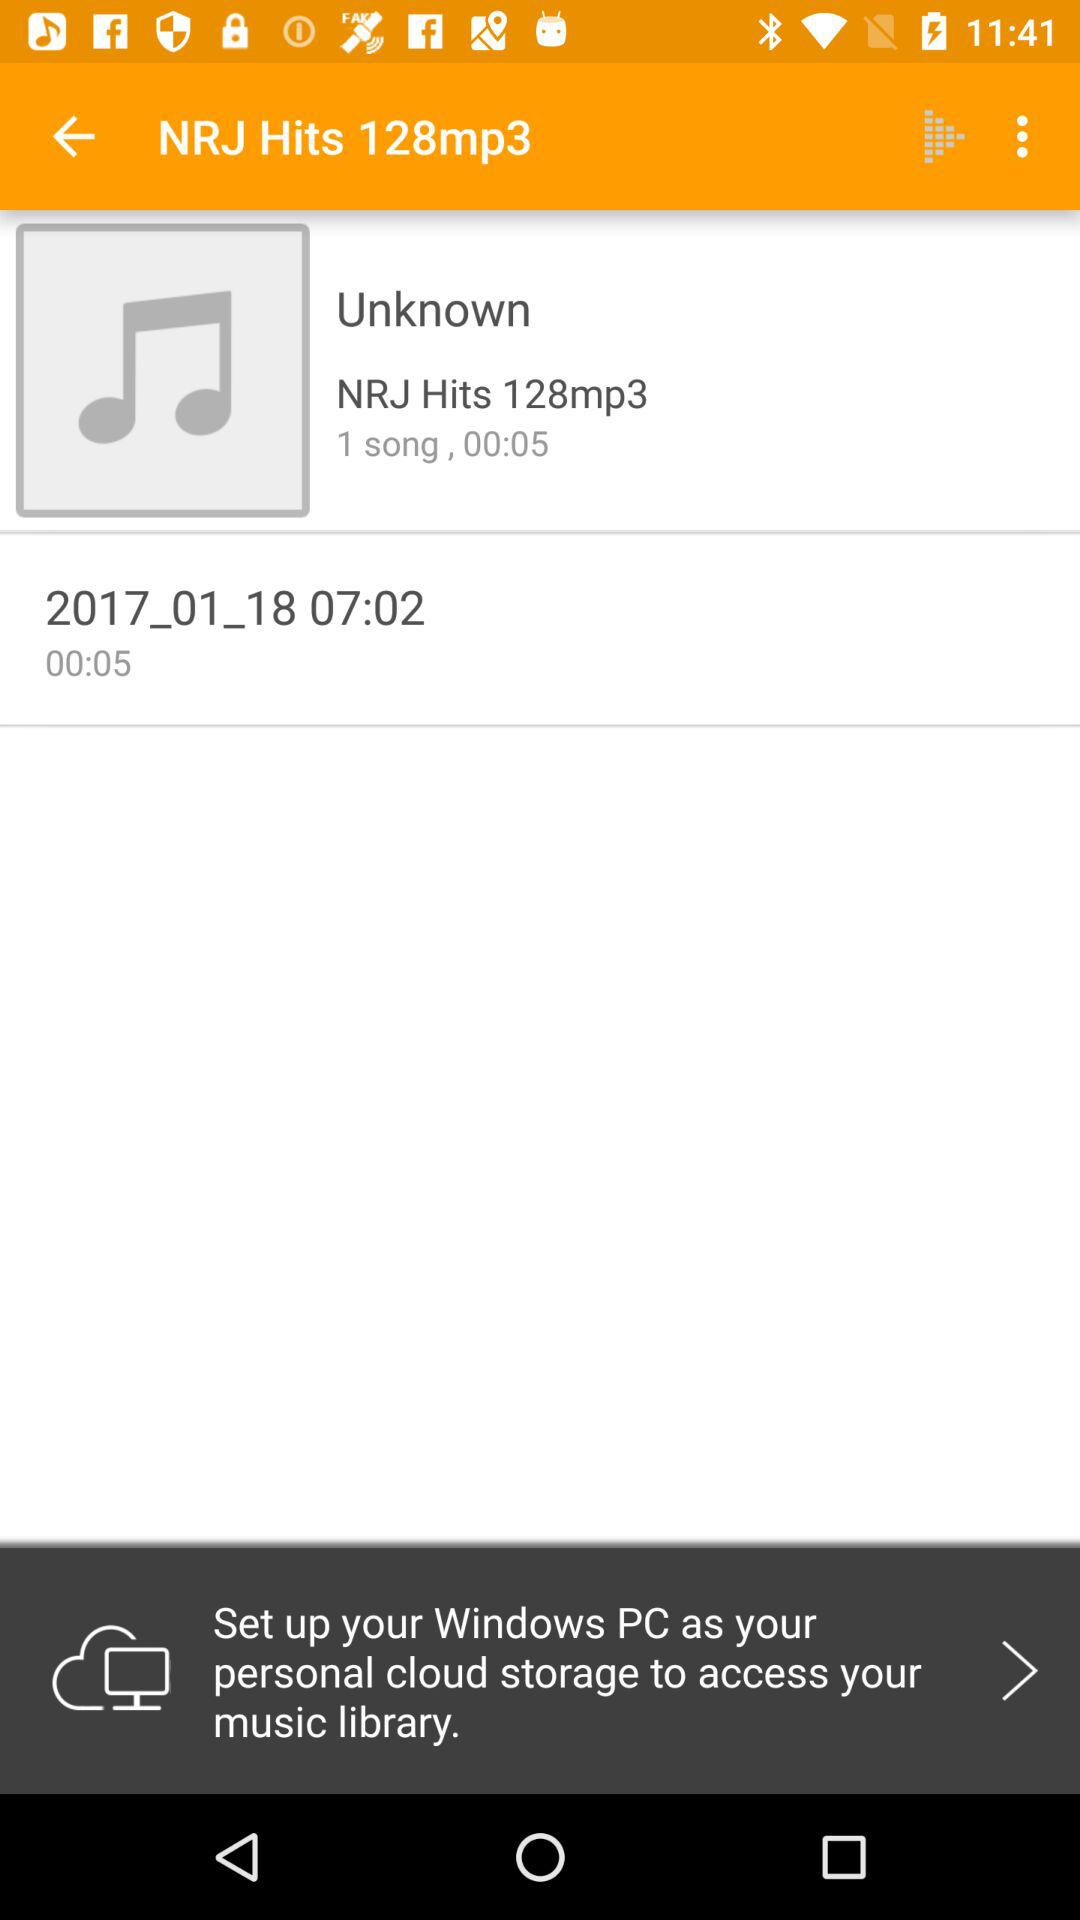What is the time duration of the song? The time duration of the song is 5 seconds. 